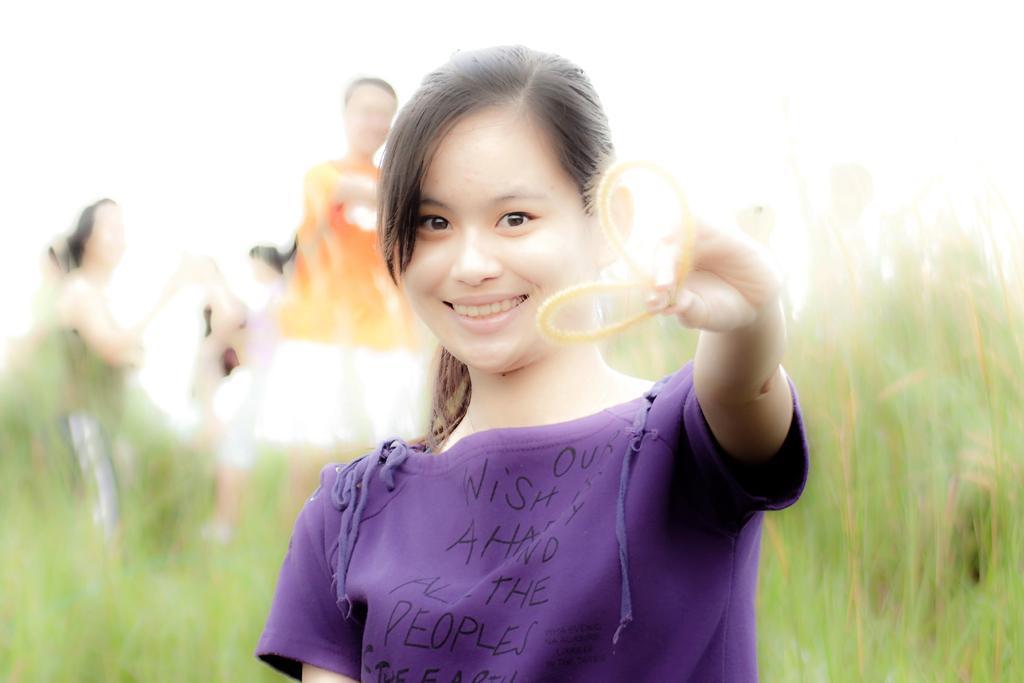Could you give a brief overview of what you see in this image? In this image I can see a girl holding an object. There are plants and other people at the back. 